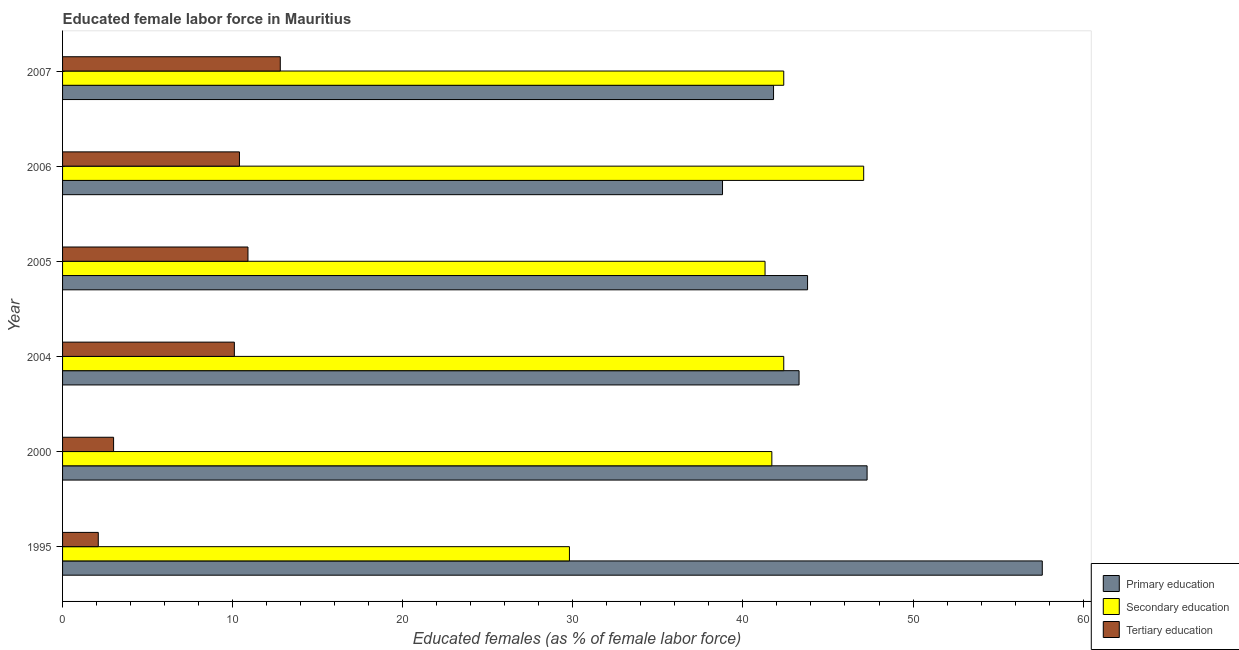How many different coloured bars are there?
Ensure brevity in your answer.  3. Are the number of bars per tick equal to the number of legend labels?
Give a very brief answer. Yes. How many bars are there on the 3rd tick from the top?
Give a very brief answer. 3. What is the label of the 1st group of bars from the top?
Ensure brevity in your answer.  2007. What is the percentage of female labor force who received tertiary education in 2005?
Offer a terse response. 10.9. Across all years, what is the maximum percentage of female labor force who received primary education?
Give a very brief answer. 57.6. Across all years, what is the minimum percentage of female labor force who received primary education?
Offer a very short reply. 38.8. In which year was the percentage of female labor force who received tertiary education minimum?
Your response must be concise. 1995. What is the total percentage of female labor force who received secondary education in the graph?
Your answer should be very brief. 244.7. What is the difference between the percentage of female labor force who received secondary education in 2000 and the percentage of female labor force who received primary education in 2005?
Provide a succinct answer. -2.1. What is the average percentage of female labor force who received secondary education per year?
Provide a short and direct response. 40.78. In the year 2000, what is the difference between the percentage of female labor force who received tertiary education and percentage of female labor force who received secondary education?
Keep it short and to the point. -38.7. Is the percentage of female labor force who received secondary education in 1995 less than that in 2000?
Your answer should be very brief. Yes. What is the difference between the highest and the second highest percentage of female labor force who received tertiary education?
Provide a succinct answer. 1.9. In how many years, is the percentage of female labor force who received tertiary education greater than the average percentage of female labor force who received tertiary education taken over all years?
Offer a very short reply. 4. Is the sum of the percentage of female labor force who received secondary education in 2004 and 2005 greater than the maximum percentage of female labor force who received primary education across all years?
Your response must be concise. Yes. What does the 1st bar from the top in 2000 represents?
Your answer should be very brief. Tertiary education. What does the 1st bar from the bottom in 1995 represents?
Provide a short and direct response. Primary education. Is it the case that in every year, the sum of the percentage of female labor force who received primary education and percentage of female labor force who received secondary education is greater than the percentage of female labor force who received tertiary education?
Your answer should be compact. Yes. How many bars are there?
Provide a succinct answer. 18. Are all the bars in the graph horizontal?
Give a very brief answer. Yes. What is the difference between two consecutive major ticks on the X-axis?
Make the answer very short. 10. Are the values on the major ticks of X-axis written in scientific E-notation?
Ensure brevity in your answer.  No. Does the graph contain any zero values?
Provide a short and direct response. No. How are the legend labels stacked?
Provide a short and direct response. Vertical. What is the title of the graph?
Give a very brief answer. Educated female labor force in Mauritius. What is the label or title of the X-axis?
Give a very brief answer. Educated females (as % of female labor force). What is the label or title of the Y-axis?
Your response must be concise. Year. What is the Educated females (as % of female labor force) in Primary education in 1995?
Make the answer very short. 57.6. What is the Educated females (as % of female labor force) in Secondary education in 1995?
Provide a succinct answer. 29.8. What is the Educated females (as % of female labor force) of Tertiary education in 1995?
Provide a succinct answer. 2.1. What is the Educated females (as % of female labor force) of Primary education in 2000?
Your answer should be compact. 47.3. What is the Educated females (as % of female labor force) of Secondary education in 2000?
Your answer should be very brief. 41.7. What is the Educated females (as % of female labor force) in Primary education in 2004?
Ensure brevity in your answer.  43.3. What is the Educated females (as % of female labor force) in Secondary education in 2004?
Provide a short and direct response. 42.4. What is the Educated females (as % of female labor force) in Tertiary education in 2004?
Give a very brief answer. 10.1. What is the Educated females (as % of female labor force) in Primary education in 2005?
Provide a short and direct response. 43.8. What is the Educated females (as % of female labor force) in Secondary education in 2005?
Your answer should be very brief. 41.3. What is the Educated females (as % of female labor force) in Tertiary education in 2005?
Your answer should be compact. 10.9. What is the Educated females (as % of female labor force) of Primary education in 2006?
Make the answer very short. 38.8. What is the Educated females (as % of female labor force) of Secondary education in 2006?
Provide a short and direct response. 47.1. What is the Educated females (as % of female labor force) of Tertiary education in 2006?
Offer a terse response. 10.4. What is the Educated females (as % of female labor force) in Primary education in 2007?
Provide a succinct answer. 41.8. What is the Educated females (as % of female labor force) in Secondary education in 2007?
Ensure brevity in your answer.  42.4. What is the Educated females (as % of female labor force) in Tertiary education in 2007?
Your answer should be compact. 12.8. Across all years, what is the maximum Educated females (as % of female labor force) of Primary education?
Provide a short and direct response. 57.6. Across all years, what is the maximum Educated females (as % of female labor force) in Secondary education?
Give a very brief answer. 47.1. Across all years, what is the maximum Educated females (as % of female labor force) of Tertiary education?
Provide a succinct answer. 12.8. Across all years, what is the minimum Educated females (as % of female labor force) of Primary education?
Your answer should be very brief. 38.8. Across all years, what is the minimum Educated females (as % of female labor force) of Secondary education?
Keep it short and to the point. 29.8. Across all years, what is the minimum Educated females (as % of female labor force) of Tertiary education?
Provide a succinct answer. 2.1. What is the total Educated females (as % of female labor force) in Primary education in the graph?
Provide a short and direct response. 272.6. What is the total Educated females (as % of female labor force) in Secondary education in the graph?
Your answer should be compact. 244.7. What is the total Educated females (as % of female labor force) in Tertiary education in the graph?
Ensure brevity in your answer.  49.3. What is the difference between the Educated females (as % of female labor force) in Primary education in 1995 and that in 2000?
Offer a terse response. 10.3. What is the difference between the Educated females (as % of female labor force) in Secondary education in 1995 and that in 2000?
Provide a short and direct response. -11.9. What is the difference between the Educated females (as % of female labor force) in Primary education in 1995 and that in 2004?
Give a very brief answer. 14.3. What is the difference between the Educated females (as % of female labor force) of Tertiary education in 1995 and that in 2004?
Offer a terse response. -8. What is the difference between the Educated females (as % of female labor force) of Primary education in 1995 and that in 2005?
Offer a terse response. 13.8. What is the difference between the Educated females (as % of female labor force) in Secondary education in 1995 and that in 2005?
Your answer should be compact. -11.5. What is the difference between the Educated females (as % of female labor force) in Tertiary education in 1995 and that in 2005?
Your response must be concise. -8.8. What is the difference between the Educated females (as % of female labor force) in Primary education in 1995 and that in 2006?
Give a very brief answer. 18.8. What is the difference between the Educated females (as % of female labor force) in Secondary education in 1995 and that in 2006?
Give a very brief answer. -17.3. What is the difference between the Educated females (as % of female labor force) in Primary education in 1995 and that in 2007?
Offer a terse response. 15.8. What is the difference between the Educated females (as % of female labor force) in Secondary education in 1995 and that in 2007?
Your answer should be compact. -12.6. What is the difference between the Educated females (as % of female labor force) of Tertiary education in 1995 and that in 2007?
Give a very brief answer. -10.7. What is the difference between the Educated females (as % of female labor force) in Primary education in 2000 and that in 2004?
Make the answer very short. 4. What is the difference between the Educated females (as % of female labor force) in Tertiary education in 2000 and that in 2004?
Provide a succinct answer. -7.1. What is the difference between the Educated females (as % of female labor force) of Secondary education in 2000 and that in 2006?
Keep it short and to the point. -5.4. What is the difference between the Educated females (as % of female labor force) in Tertiary education in 2000 and that in 2006?
Your answer should be compact. -7.4. What is the difference between the Educated females (as % of female labor force) of Primary education in 2000 and that in 2007?
Offer a very short reply. 5.5. What is the difference between the Educated females (as % of female labor force) in Secondary education in 2000 and that in 2007?
Make the answer very short. -0.7. What is the difference between the Educated females (as % of female labor force) of Primary education in 2004 and that in 2005?
Make the answer very short. -0.5. What is the difference between the Educated females (as % of female labor force) of Secondary education in 2004 and that in 2005?
Offer a terse response. 1.1. What is the difference between the Educated females (as % of female labor force) in Tertiary education in 2004 and that in 2005?
Your answer should be very brief. -0.8. What is the difference between the Educated females (as % of female labor force) of Tertiary education in 2004 and that in 2006?
Make the answer very short. -0.3. What is the difference between the Educated females (as % of female labor force) in Primary education in 2004 and that in 2007?
Your answer should be very brief. 1.5. What is the difference between the Educated females (as % of female labor force) of Secondary education in 2004 and that in 2007?
Provide a succinct answer. 0. What is the difference between the Educated females (as % of female labor force) of Tertiary education in 2005 and that in 2006?
Give a very brief answer. 0.5. What is the difference between the Educated females (as % of female labor force) in Primary education in 2006 and that in 2007?
Provide a succinct answer. -3. What is the difference between the Educated females (as % of female labor force) in Secondary education in 2006 and that in 2007?
Offer a terse response. 4.7. What is the difference between the Educated females (as % of female labor force) in Tertiary education in 2006 and that in 2007?
Offer a very short reply. -2.4. What is the difference between the Educated females (as % of female labor force) in Primary education in 1995 and the Educated females (as % of female labor force) in Secondary education in 2000?
Provide a short and direct response. 15.9. What is the difference between the Educated females (as % of female labor force) in Primary education in 1995 and the Educated females (as % of female labor force) in Tertiary education in 2000?
Provide a succinct answer. 54.6. What is the difference between the Educated females (as % of female labor force) of Secondary education in 1995 and the Educated females (as % of female labor force) of Tertiary education in 2000?
Provide a short and direct response. 26.8. What is the difference between the Educated females (as % of female labor force) in Primary education in 1995 and the Educated females (as % of female labor force) in Tertiary education in 2004?
Offer a very short reply. 47.5. What is the difference between the Educated females (as % of female labor force) of Primary education in 1995 and the Educated females (as % of female labor force) of Tertiary education in 2005?
Offer a very short reply. 46.7. What is the difference between the Educated females (as % of female labor force) of Secondary education in 1995 and the Educated females (as % of female labor force) of Tertiary education in 2005?
Offer a terse response. 18.9. What is the difference between the Educated females (as % of female labor force) in Primary education in 1995 and the Educated females (as % of female labor force) in Secondary education in 2006?
Ensure brevity in your answer.  10.5. What is the difference between the Educated females (as % of female labor force) in Primary education in 1995 and the Educated females (as % of female labor force) in Tertiary education in 2006?
Ensure brevity in your answer.  47.2. What is the difference between the Educated females (as % of female labor force) of Secondary education in 1995 and the Educated females (as % of female labor force) of Tertiary education in 2006?
Your answer should be very brief. 19.4. What is the difference between the Educated females (as % of female labor force) in Primary education in 1995 and the Educated females (as % of female labor force) in Tertiary education in 2007?
Your answer should be compact. 44.8. What is the difference between the Educated females (as % of female labor force) of Secondary education in 1995 and the Educated females (as % of female labor force) of Tertiary education in 2007?
Your answer should be very brief. 17. What is the difference between the Educated females (as % of female labor force) in Primary education in 2000 and the Educated females (as % of female labor force) in Tertiary education in 2004?
Ensure brevity in your answer.  37.2. What is the difference between the Educated females (as % of female labor force) in Secondary education in 2000 and the Educated females (as % of female labor force) in Tertiary education in 2004?
Offer a terse response. 31.6. What is the difference between the Educated females (as % of female labor force) of Primary education in 2000 and the Educated females (as % of female labor force) of Tertiary education in 2005?
Make the answer very short. 36.4. What is the difference between the Educated females (as % of female labor force) of Secondary education in 2000 and the Educated females (as % of female labor force) of Tertiary education in 2005?
Provide a short and direct response. 30.8. What is the difference between the Educated females (as % of female labor force) of Primary education in 2000 and the Educated females (as % of female labor force) of Secondary education in 2006?
Make the answer very short. 0.2. What is the difference between the Educated females (as % of female labor force) of Primary education in 2000 and the Educated females (as % of female labor force) of Tertiary education in 2006?
Offer a terse response. 36.9. What is the difference between the Educated females (as % of female labor force) in Secondary education in 2000 and the Educated females (as % of female labor force) in Tertiary education in 2006?
Your answer should be compact. 31.3. What is the difference between the Educated females (as % of female labor force) in Primary education in 2000 and the Educated females (as % of female labor force) in Tertiary education in 2007?
Ensure brevity in your answer.  34.5. What is the difference between the Educated females (as % of female labor force) in Secondary education in 2000 and the Educated females (as % of female labor force) in Tertiary education in 2007?
Your answer should be compact. 28.9. What is the difference between the Educated females (as % of female labor force) of Primary education in 2004 and the Educated females (as % of female labor force) of Tertiary education in 2005?
Make the answer very short. 32.4. What is the difference between the Educated females (as % of female labor force) of Secondary education in 2004 and the Educated females (as % of female labor force) of Tertiary education in 2005?
Make the answer very short. 31.5. What is the difference between the Educated females (as % of female labor force) of Primary education in 2004 and the Educated females (as % of female labor force) of Secondary education in 2006?
Make the answer very short. -3.8. What is the difference between the Educated females (as % of female labor force) in Primary education in 2004 and the Educated females (as % of female labor force) in Tertiary education in 2006?
Your answer should be compact. 32.9. What is the difference between the Educated females (as % of female labor force) of Primary education in 2004 and the Educated females (as % of female labor force) of Secondary education in 2007?
Your answer should be very brief. 0.9. What is the difference between the Educated females (as % of female labor force) in Primary education in 2004 and the Educated females (as % of female labor force) in Tertiary education in 2007?
Provide a succinct answer. 30.5. What is the difference between the Educated females (as % of female labor force) of Secondary education in 2004 and the Educated females (as % of female labor force) of Tertiary education in 2007?
Provide a short and direct response. 29.6. What is the difference between the Educated females (as % of female labor force) in Primary education in 2005 and the Educated females (as % of female labor force) in Secondary education in 2006?
Ensure brevity in your answer.  -3.3. What is the difference between the Educated females (as % of female labor force) in Primary education in 2005 and the Educated females (as % of female labor force) in Tertiary education in 2006?
Provide a succinct answer. 33.4. What is the difference between the Educated females (as % of female labor force) of Secondary education in 2005 and the Educated females (as % of female labor force) of Tertiary education in 2006?
Provide a succinct answer. 30.9. What is the difference between the Educated females (as % of female labor force) in Primary education in 2005 and the Educated females (as % of female labor force) in Tertiary education in 2007?
Offer a very short reply. 31. What is the difference between the Educated females (as % of female labor force) in Primary education in 2006 and the Educated females (as % of female labor force) in Tertiary education in 2007?
Make the answer very short. 26. What is the difference between the Educated females (as % of female labor force) of Secondary education in 2006 and the Educated females (as % of female labor force) of Tertiary education in 2007?
Offer a very short reply. 34.3. What is the average Educated females (as % of female labor force) in Primary education per year?
Make the answer very short. 45.43. What is the average Educated females (as % of female labor force) of Secondary education per year?
Give a very brief answer. 40.78. What is the average Educated females (as % of female labor force) in Tertiary education per year?
Offer a very short reply. 8.22. In the year 1995, what is the difference between the Educated females (as % of female labor force) of Primary education and Educated females (as % of female labor force) of Secondary education?
Offer a terse response. 27.8. In the year 1995, what is the difference between the Educated females (as % of female labor force) in Primary education and Educated females (as % of female labor force) in Tertiary education?
Offer a terse response. 55.5. In the year 1995, what is the difference between the Educated females (as % of female labor force) of Secondary education and Educated females (as % of female labor force) of Tertiary education?
Keep it short and to the point. 27.7. In the year 2000, what is the difference between the Educated females (as % of female labor force) in Primary education and Educated females (as % of female labor force) in Tertiary education?
Ensure brevity in your answer.  44.3. In the year 2000, what is the difference between the Educated females (as % of female labor force) of Secondary education and Educated females (as % of female labor force) of Tertiary education?
Provide a succinct answer. 38.7. In the year 2004, what is the difference between the Educated females (as % of female labor force) of Primary education and Educated females (as % of female labor force) of Tertiary education?
Offer a terse response. 33.2. In the year 2004, what is the difference between the Educated females (as % of female labor force) of Secondary education and Educated females (as % of female labor force) of Tertiary education?
Your answer should be very brief. 32.3. In the year 2005, what is the difference between the Educated females (as % of female labor force) of Primary education and Educated females (as % of female labor force) of Tertiary education?
Provide a short and direct response. 32.9. In the year 2005, what is the difference between the Educated females (as % of female labor force) of Secondary education and Educated females (as % of female labor force) of Tertiary education?
Your answer should be compact. 30.4. In the year 2006, what is the difference between the Educated females (as % of female labor force) in Primary education and Educated females (as % of female labor force) in Tertiary education?
Provide a succinct answer. 28.4. In the year 2006, what is the difference between the Educated females (as % of female labor force) in Secondary education and Educated females (as % of female labor force) in Tertiary education?
Offer a terse response. 36.7. In the year 2007, what is the difference between the Educated females (as % of female labor force) in Primary education and Educated females (as % of female labor force) in Secondary education?
Offer a very short reply. -0.6. In the year 2007, what is the difference between the Educated females (as % of female labor force) in Primary education and Educated females (as % of female labor force) in Tertiary education?
Provide a short and direct response. 29. In the year 2007, what is the difference between the Educated females (as % of female labor force) in Secondary education and Educated females (as % of female labor force) in Tertiary education?
Your response must be concise. 29.6. What is the ratio of the Educated females (as % of female labor force) of Primary education in 1995 to that in 2000?
Give a very brief answer. 1.22. What is the ratio of the Educated females (as % of female labor force) of Secondary education in 1995 to that in 2000?
Keep it short and to the point. 0.71. What is the ratio of the Educated females (as % of female labor force) in Primary education in 1995 to that in 2004?
Offer a very short reply. 1.33. What is the ratio of the Educated females (as % of female labor force) of Secondary education in 1995 to that in 2004?
Make the answer very short. 0.7. What is the ratio of the Educated females (as % of female labor force) of Tertiary education in 1995 to that in 2004?
Your answer should be compact. 0.21. What is the ratio of the Educated females (as % of female labor force) of Primary education in 1995 to that in 2005?
Provide a succinct answer. 1.32. What is the ratio of the Educated females (as % of female labor force) in Secondary education in 1995 to that in 2005?
Offer a terse response. 0.72. What is the ratio of the Educated females (as % of female labor force) in Tertiary education in 1995 to that in 2005?
Your response must be concise. 0.19. What is the ratio of the Educated females (as % of female labor force) in Primary education in 1995 to that in 2006?
Keep it short and to the point. 1.48. What is the ratio of the Educated females (as % of female labor force) in Secondary education in 1995 to that in 2006?
Your answer should be compact. 0.63. What is the ratio of the Educated females (as % of female labor force) in Tertiary education in 1995 to that in 2006?
Provide a succinct answer. 0.2. What is the ratio of the Educated females (as % of female labor force) of Primary education in 1995 to that in 2007?
Make the answer very short. 1.38. What is the ratio of the Educated females (as % of female labor force) of Secondary education in 1995 to that in 2007?
Offer a terse response. 0.7. What is the ratio of the Educated females (as % of female labor force) of Tertiary education in 1995 to that in 2007?
Make the answer very short. 0.16. What is the ratio of the Educated females (as % of female labor force) in Primary education in 2000 to that in 2004?
Your response must be concise. 1.09. What is the ratio of the Educated females (as % of female labor force) of Secondary education in 2000 to that in 2004?
Ensure brevity in your answer.  0.98. What is the ratio of the Educated females (as % of female labor force) in Tertiary education in 2000 to that in 2004?
Provide a succinct answer. 0.3. What is the ratio of the Educated females (as % of female labor force) in Primary education in 2000 to that in 2005?
Provide a short and direct response. 1.08. What is the ratio of the Educated females (as % of female labor force) of Secondary education in 2000 to that in 2005?
Provide a short and direct response. 1.01. What is the ratio of the Educated females (as % of female labor force) of Tertiary education in 2000 to that in 2005?
Ensure brevity in your answer.  0.28. What is the ratio of the Educated females (as % of female labor force) in Primary education in 2000 to that in 2006?
Offer a terse response. 1.22. What is the ratio of the Educated females (as % of female labor force) in Secondary education in 2000 to that in 2006?
Your response must be concise. 0.89. What is the ratio of the Educated females (as % of female labor force) in Tertiary education in 2000 to that in 2006?
Your response must be concise. 0.29. What is the ratio of the Educated females (as % of female labor force) of Primary education in 2000 to that in 2007?
Your answer should be compact. 1.13. What is the ratio of the Educated females (as % of female labor force) of Secondary education in 2000 to that in 2007?
Offer a very short reply. 0.98. What is the ratio of the Educated females (as % of female labor force) in Tertiary education in 2000 to that in 2007?
Offer a very short reply. 0.23. What is the ratio of the Educated females (as % of female labor force) in Secondary education in 2004 to that in 2005?
Offer a terse response. 1.03. What is the ratio of the Educated females (as % of female labor force) of Tertiary education in 2004 to that in 2005?
Keep it short and to the point. 0.93. What is the ratio of the Educated females (as % of female labor force) in Primary education in 2004 to that in 2006?
Your answer should be very brief. 1.12. What is the ratio of the Educated females (as % of female labor force) in Secondary education in 2004 to that in 2006?
Your answer should be very brief. 0.9. What is the ratio of the Educated females (as % of female labor force) in Tertiary education in 2004 to that in 2006?
Provide a succinct answer. 0.97. What is the ratio of the Educated females (as % of female labor force) in Primary education in 2004 to that in 2007?
Your answer should be very brief. 1.04. What is the ratio of the Educated females (as % of female labor force) in Tertiary education in 2004 to that in 2007?
Your response must be concise. 0.79. What is the ratio of the Educated females (as % of female labor force) of Primary education in 2005 to that in 2006?
Provide a short and direct response. 1.13. What is the ratio of the Educated females (as % of female labor force) in Secondary education in 2005 to that in 2006?
Ensure brevity in your answer.  0.88. What is the ratio of the Educated females (as % of female labor force) in Tertiary education in 2005 to that in 2006?
Your answer should be compact. 1.05. What is the ratio of the Educated females (as % of female labor force) of Primary education in 2005 to that in 2007?
Your response must be concise. 1.05. What is the ratio of the Educated females (as % of female labor force) in Secondary education in 2005 to that in 2007?
Provide a succinct answer. 0.97. What is the ratio of the Educated females (as % of female labor force) of Tertiary education in 2005 to that in 2007?
Ensure brevity in your answer.  0.85. What is the ratio of the Educated females (as % of female labor force) of Primary education in 2006 to that in 2007?
Ensure brevity in your answer.  0.93. What is the ratio of the Educated females (as % of female labor force) in Secondary education in 2006 to that in 2007?
Your response must be concise. 1.11. What is the ratio of the Educated females (as % of female labor force) in Tertiary education in 2006 to that in 2007?
Provide a succinct answer. 0.81. What is the difference between the highest and the second highest Educated females (as % of female labor force) of Tertiary education?
Ensure brevity in your answer.  1.9. 